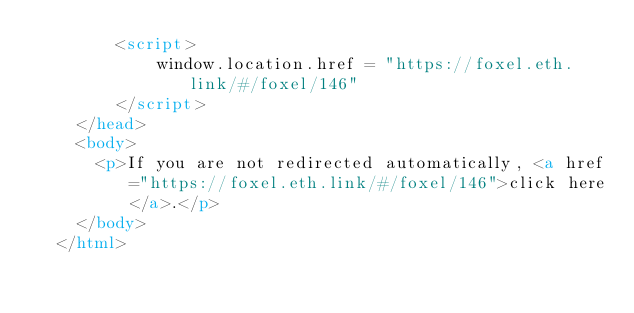<code> <loc_0><loc_0><loc_500><loc_500><_HTML_>        <script>
            window.location.href = "https://foxel.eth.link/#/foxel/146"
        </script>
    </head>
    <body>
      <p>If you are not redirected automatically, <a href="https://foxel.eth.link/#/foxel/146">click here</a>.</p>
    </body>
  </html></code> 